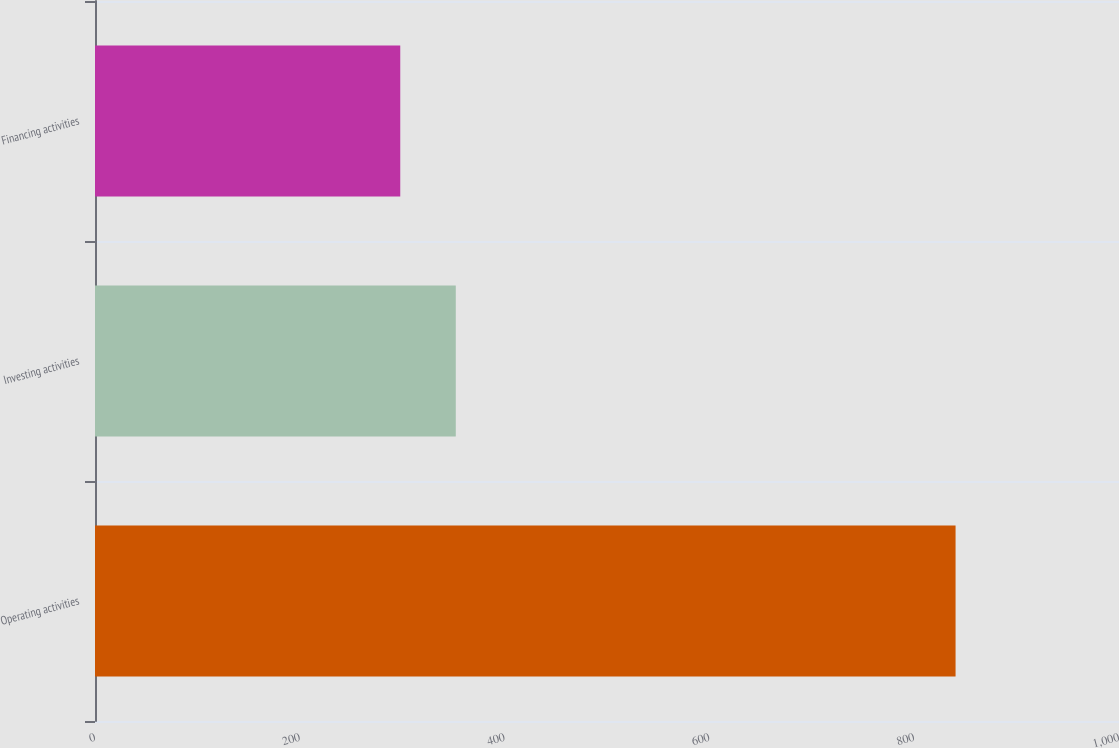Convert chart. <chart><loc_0><loc_0><loc_500><loc_500><bar_chart><fcel>Operating activities<fcel>Investing activities<fcel>Financing activities<nl><fcel>840.4<fcel>352.33<fcel>298.1<nl></chart> 